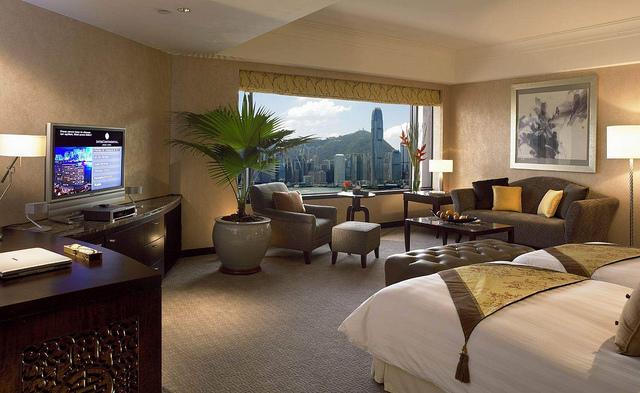Where is the view of the skyline?
Keep it brief. Window. What kind of tree is in the pot?
Answer briefly. Palm. Is there a grill outside?
Be succinct. No. What is located behind the buildings in the window?
Short answer required. Mountains. 